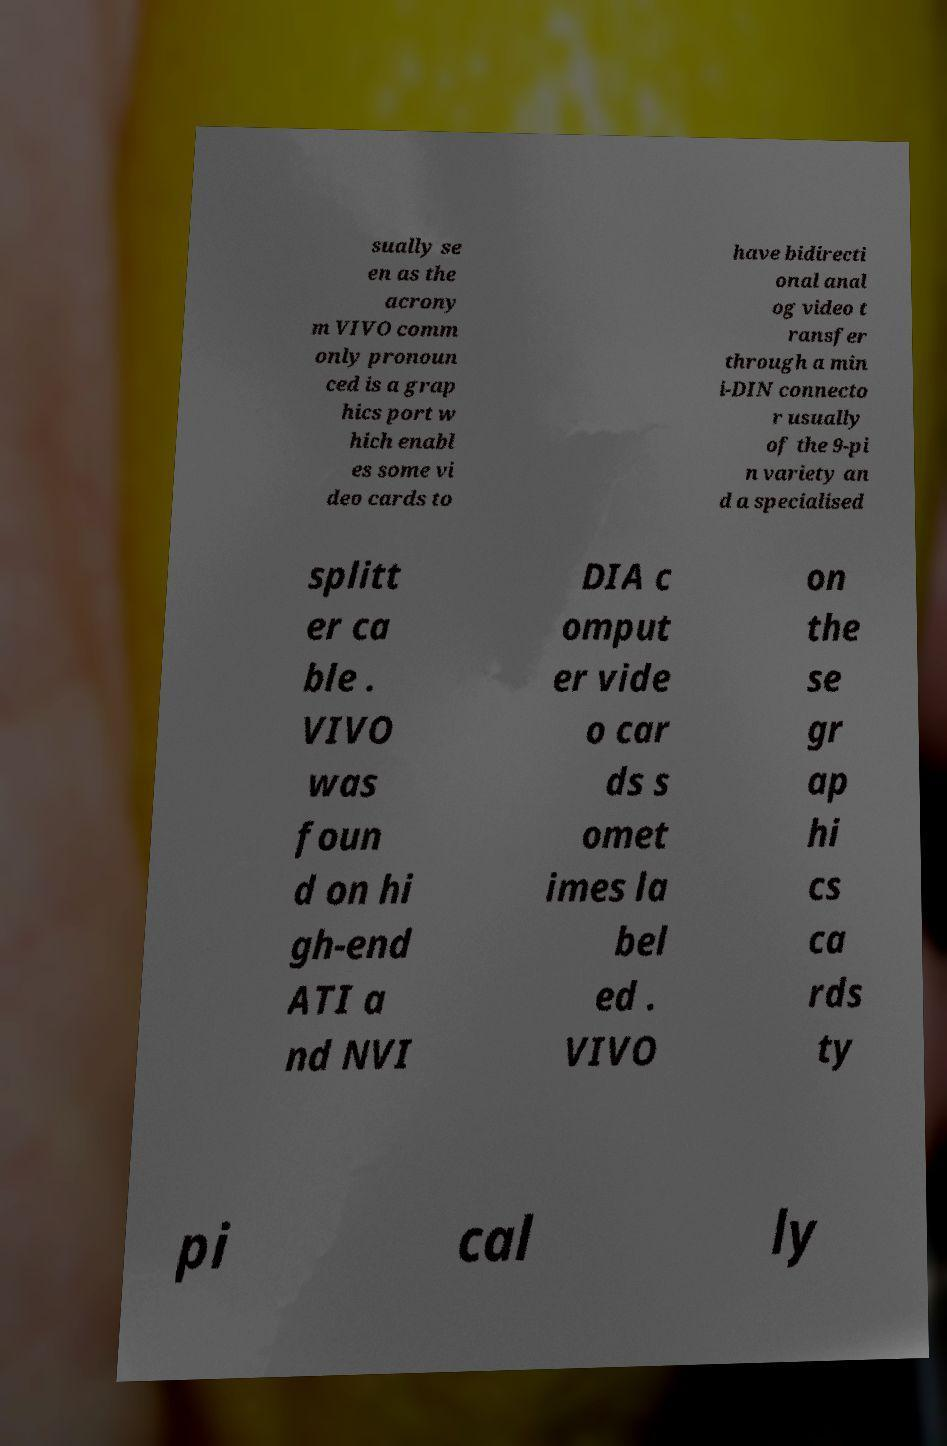Can you accurately transcribe the text from the provided image for me? sually se en as the acrony m VIVO comm only pronoun ced is a grap hics port w hich enabl es some vi deo cards to have bidirecti onal anal og video t ransfer through a min i-DIN connecto r usually of the 9-pi n variety an d a specialised splitt er ca ble . VIVO was foun d on hi gh-end ATI a nd NVI DIA c omput er vide o car ds s omet imes la bel ed . VIVO on the se gr ap hi cs ca rds ty pi cal ly 